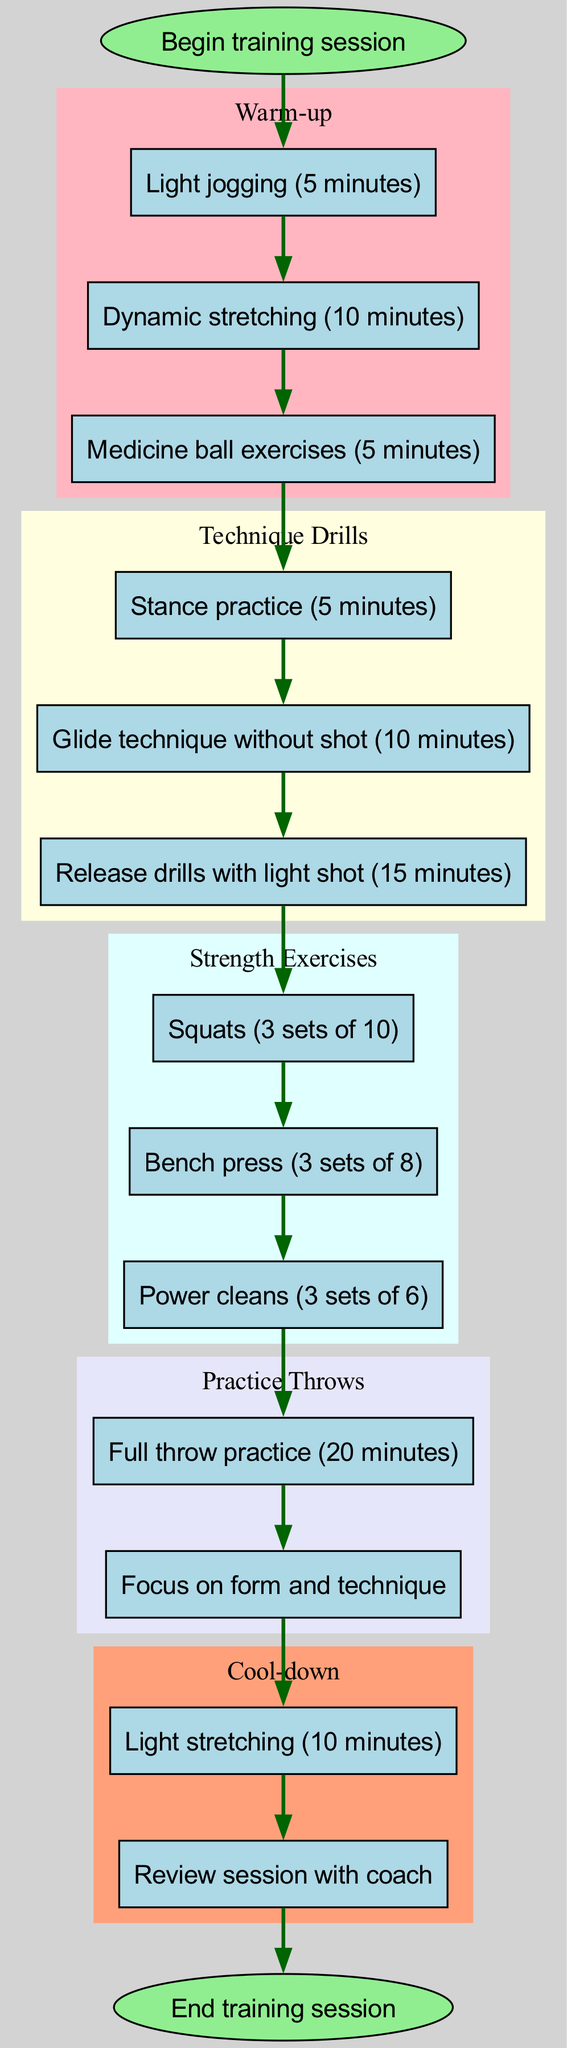What is the first step in the training session? The diagram specifies that the training session begins with the "Begin training session" node. This is the start node that initiates the entire flow of the training regimen.
Answer: Begin training session How many warm-up activities are listed? From the warm-up section in the diagram, there are three specific activities mentioned: Light jogging, Dynamic stretching, and Medicine ball exercises. Therefore, the count includes these three items.
Answer: 3 What is the last item in the cool-down section? The cool-down section lists two activities: Light stretching and Review session with coach. The last item in this section is therefore the second item in the list, which is the Review session with coach.
Answer: Review session with coach What follows the strength exercises? According to the flow of the diagram, after completing the strength exercises, the next section is Practice Throws. This sequence leads from the strength exercises directly into practice throws.
Answer: Practice Throws How many sets of squats are included in the strength exercises? The strength exercises in the diagram clearly mention "Squats (3 sets of 10)." Thus, the number of sets specifically indicated in the diagram for squats is three.
Answer: 3 sets What are the two main components following the warm-up? The flow of the diagram outlines that after the warm-up activities, the subsequent sections are Technique Drills and then Strength Exercises. Both these components are distinctly noted following the warm-up.
Answer: Technique Drills and Strength Exercises Which section contains the activity that emphasizes form and technique? The diagram connects the practice throws section with the note "Focus on form and technique." This indicates that the activity related to form and technique is located within the practice throws section.
Answer: Practice Throws How does the training session conclude? The final component of the training session, as depicted in the diagram, is the "End training session," which follows after the cool-down activities are completed. Therefore, the conclusion of the session is declared there.
Answer: End training session 